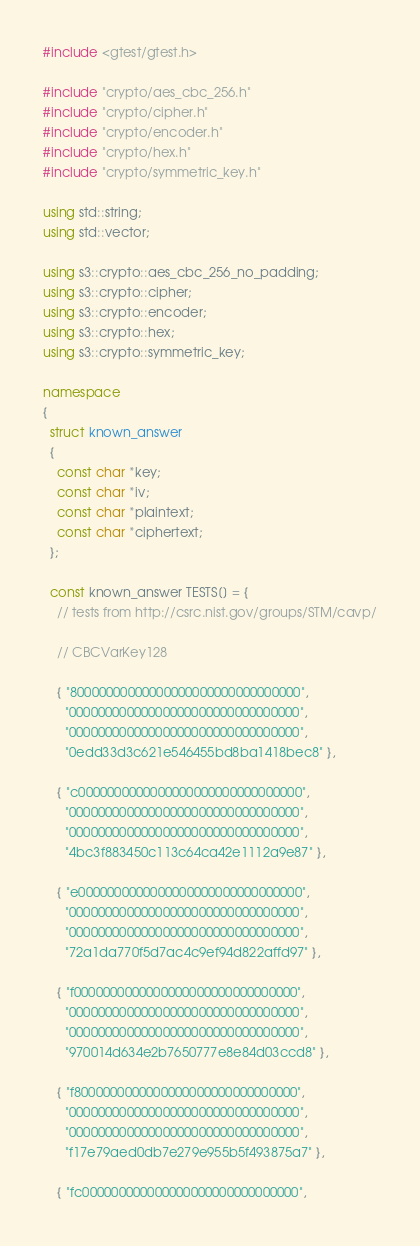Convert code to text. <code><loc_0><loc_0><loc_500><loc_500><_C++_>#include <gtest/gtest.h>

#include "crypto/aes_cbc_256.h"
#include "crypto/cipher.h"
#include "crypto/encoder.h"
#include "crypto/hex.h"
#include "crypto/symmetric_key.h"

using std::string;
using std::vector;

using s3::crypto::aes_cbc_256_no_padding;
using s3::crypto::cipher;
using s3::crypto::encoder;
using s3::crypto::hex;
using s3::crypto::symmetric_key;

namespace
{
  struct known_answer
  {
    const char *key;
    const char *iv;
    const char *plaintext;
    const char *ciphertext;
  };

  const known_answer TESTS[] = {
    // tests from http://csrc.nist.gov/groups/STM/cavp/

    // CBCVarKey128

    { "80000000000000000000000000000000",
      "00000000000000000000000000000000",
      "00000000000000000000000000000000",
      "0edd33d3c621e546455bd8ba1418bec8" },

    { "c0000000000000000000000000000000",
      "00000000000000000000000000000000",
      "00000000000000000000000000000000",
      "4bc3f883450c113c64ca42e1112a9e87" },

    { "e0000000000000000000000000000000",
      "00000000000000000000000000000000",
      "00000000000000000000000000000000",
      "72a1da770f5d7ac4c9ef94d822affd97" },

    { "f0000000000000000000000000000000",
      "00000000000000000000000000000000",
      "00000000000000000000000000000000",
      "970014d634e2b7650777e8e84d03ccd8" },

    { "f8000000000000000000000000000000",
      "00000000000000000000000000000000",
      "00000000000000000000000000000000",
      "f17e79aed0db7e279e955b5f493875a7" },

    { "fc000000000000000000000000000000",</code> 